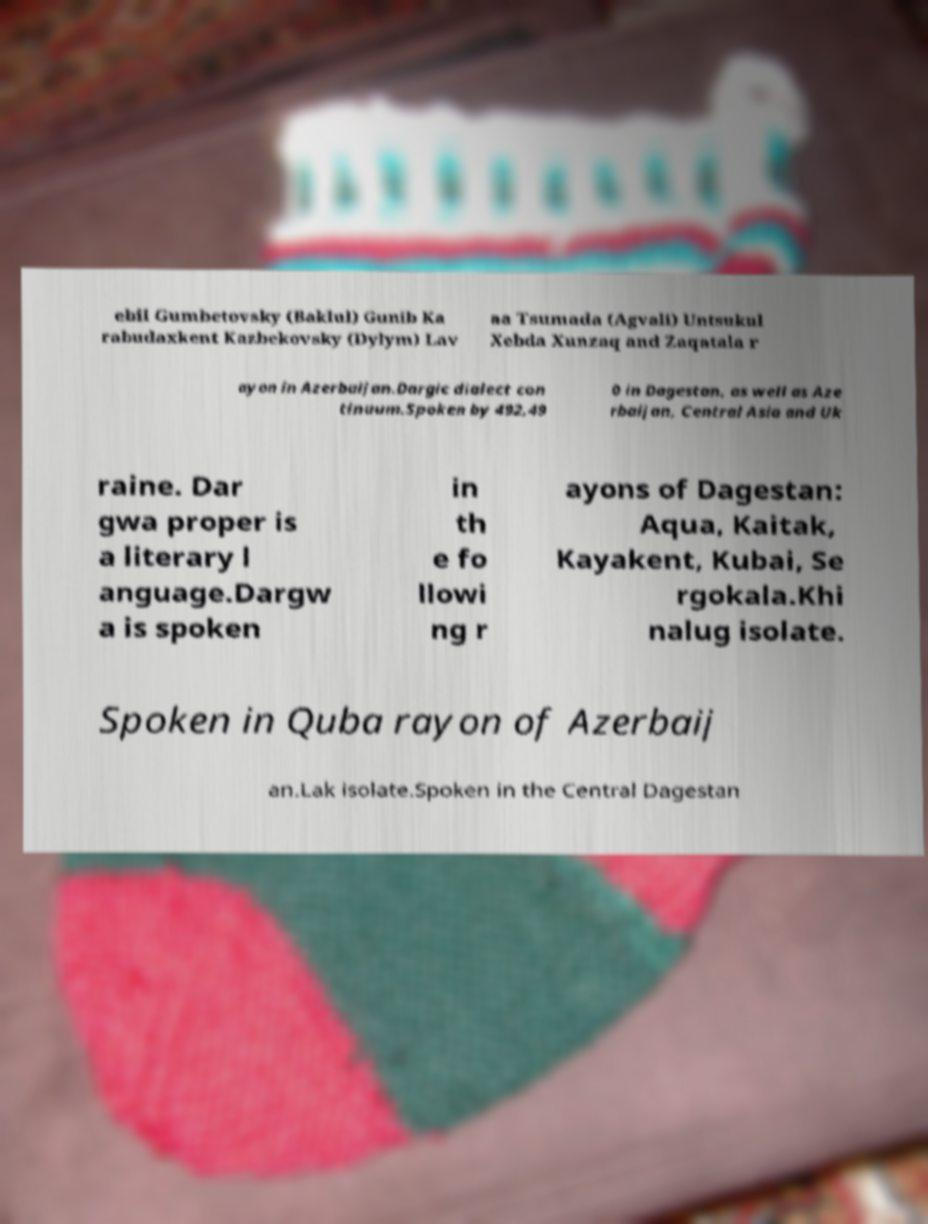Please identify and transcribe the text found in this image. ebil Gumbetovsky (Baklul) Gunib Ka rabudaxkent Kazbekovsky (Dylym) Lav aa Tsumada (Agvali) Untsukul Xebda Xunzaq and Zaqatala r ayon in Azerbaijan.Dargic dialect con tinuum.Spoken by 492,49 0 in Dagestan, as well as Aze rbaijan, Central Asia and Uk raine. Dar gwa proper is a literary l anguage.Dargw a is spoken in th e fo llowi ng r ayons of Dagestan: Aqua, Kaitak, Kayakent, Kubai, Se rgokala.Khi nalug isolate. Spoken in Quba rayon of Azerbaij an.Lak isolate.Spoken in the Central Dagestan 